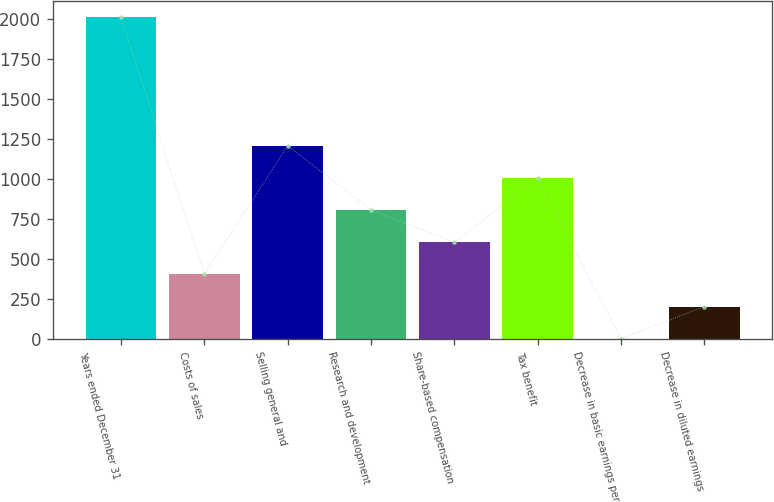Convert chart to OTSL. <chart><loc_0><loc_0><loc_500><loc_500><bar_chart><fcel>Years ended December 31<fcel>Costs of sales<fcel>Selling general and<fcel>Research and development<fcel>Share-based compensation<fcel>Tax benefit<fcel>Decrease in basic earnings per<fcel>Decrease in diluted earnings<nl><fcel>2014<fcel>403.02<fcel>1208.5<fcel>805.76<fcel>604.39<fcel>1007.13<fcel>0.28<fcel>201.65<nl></chart> 